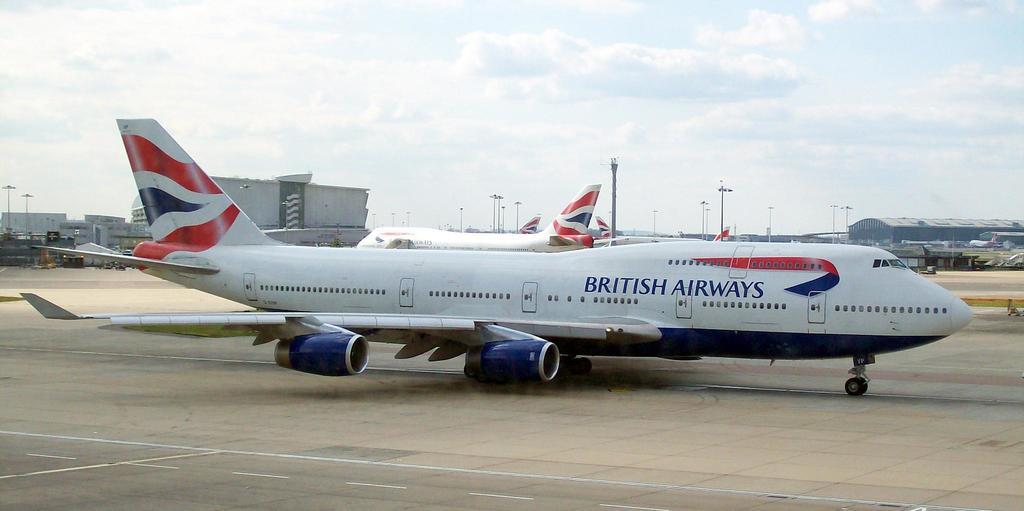What airline is this plane a part of?
Provide a succinct answer. British airways. 